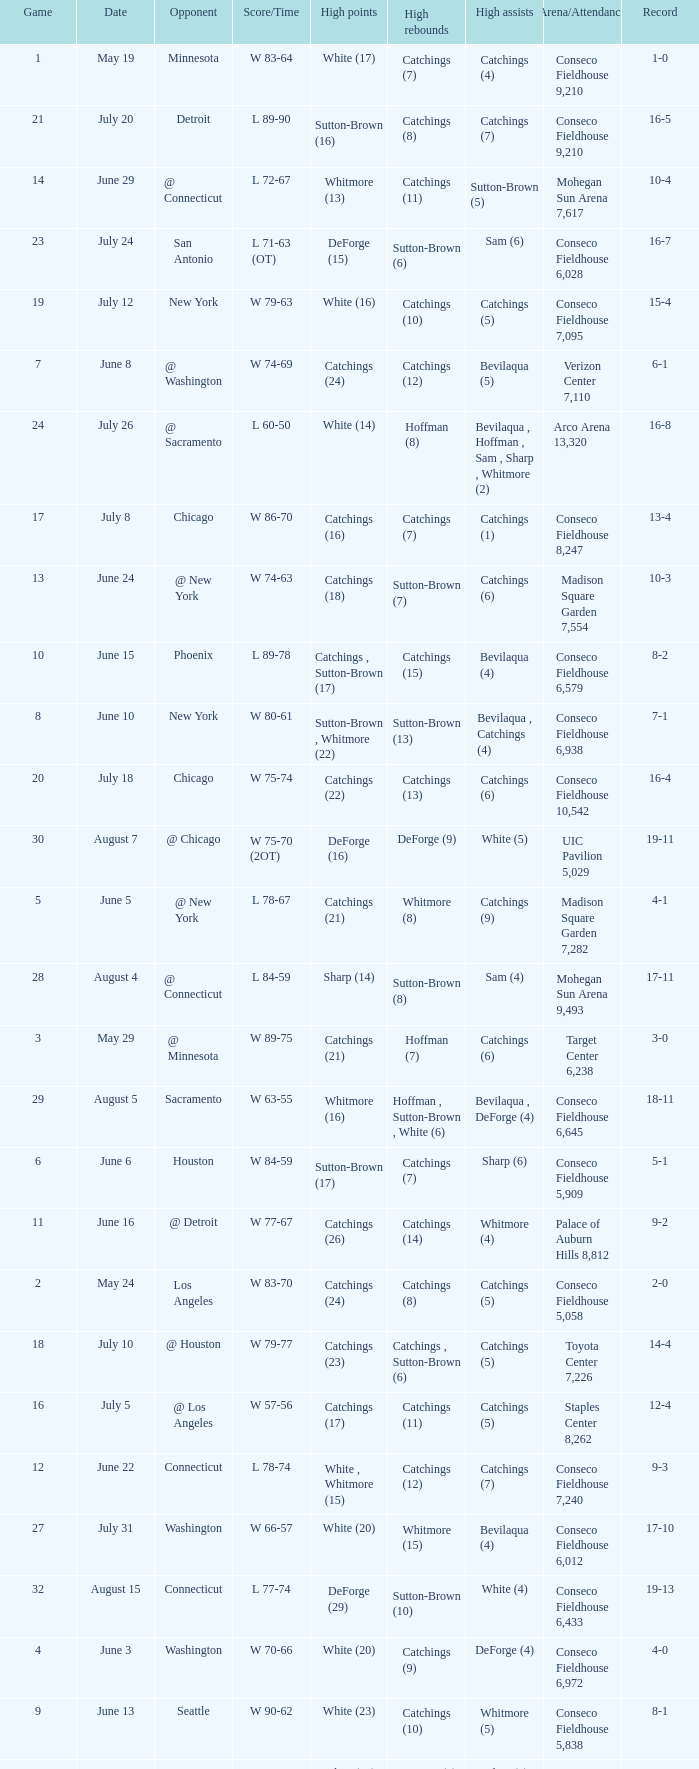Name the date where score time is w 74-63 June 24. 